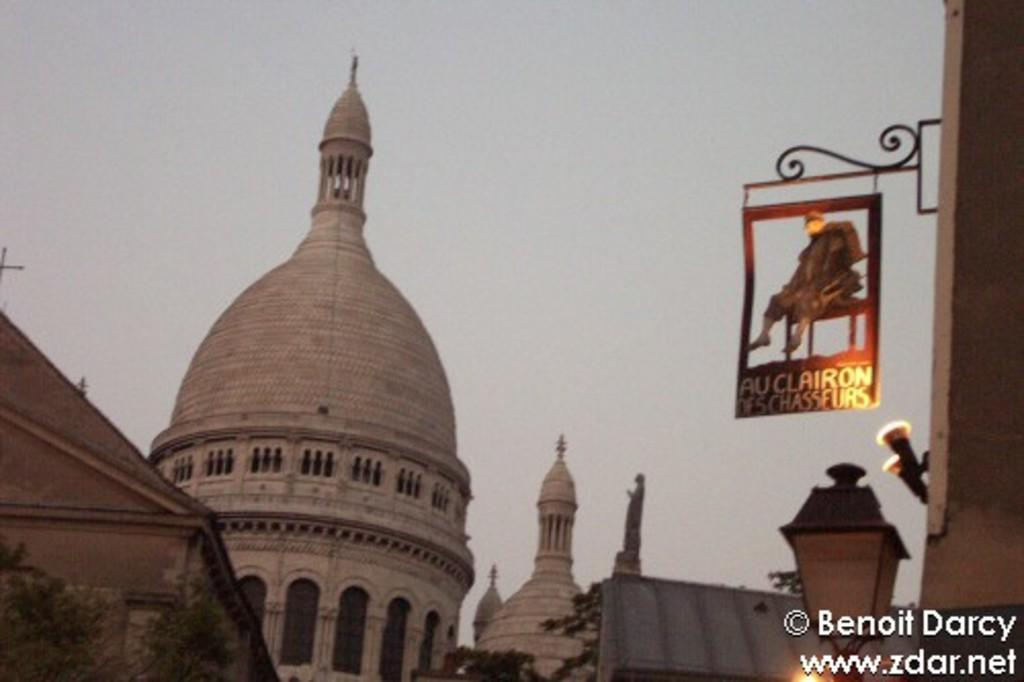What type of structures can be seen in the image? There are buildings in the image. What other natural elements are present in the image? There are trees in the image. Are there any artificial light sources visible in the image? Yes, there are lights in the image. What object can be seen in the image that might be used for displaying information? There is a board in the image. What part of the sky is visible in the image? The sky is visible at the top of the image. What type of text can be found at the bottom of the image? There is text at the bottom of the image. Can you see an island in the image? There is no island present in the image. How many times do the lights need to be copied in the image? The image does not involve copying lights; it simply shows their presence. 